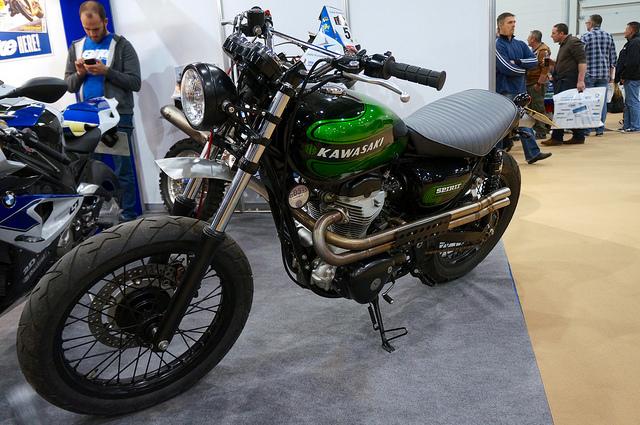What color is the gas tank?
Give a very brief answer. Green. Are these motorcycles or scooters?
Concise answer only. Motorcycles. Are these motorcycles for sale?
Concise answer only. Yes. Is this a rally?
Keep it brief. No. What color is the bike seat?
Short answer required. Gray. What make are these bikes?
Concise answer only. Kawasaki. What color is the bike's seat?
Write a very short answer. Black. What brand of motorcycle is shown?
Write a very short answer. Kawasaki. Is this outside?
Short answer required. No. Is this a police motorcycle?
Write a very short answer. No. 